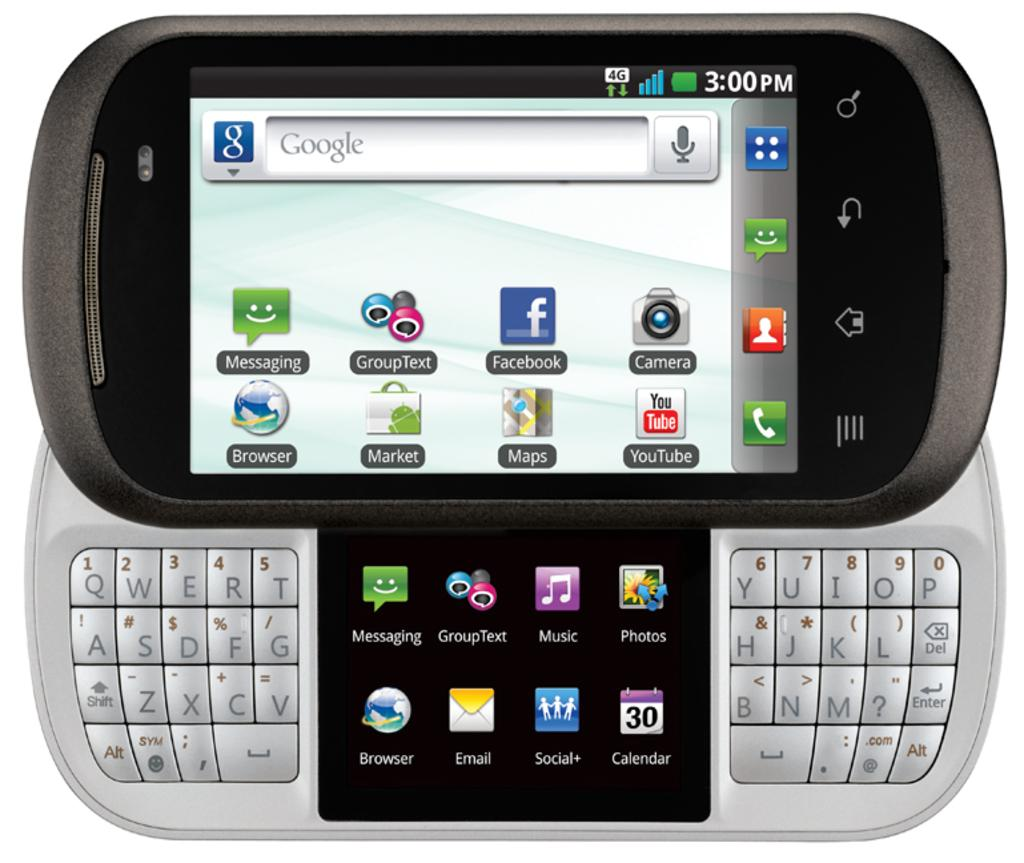<image>
Summarize the visual content of the image. The time is 3:00 PM and it is the 30th day of the month, according to this phone. 